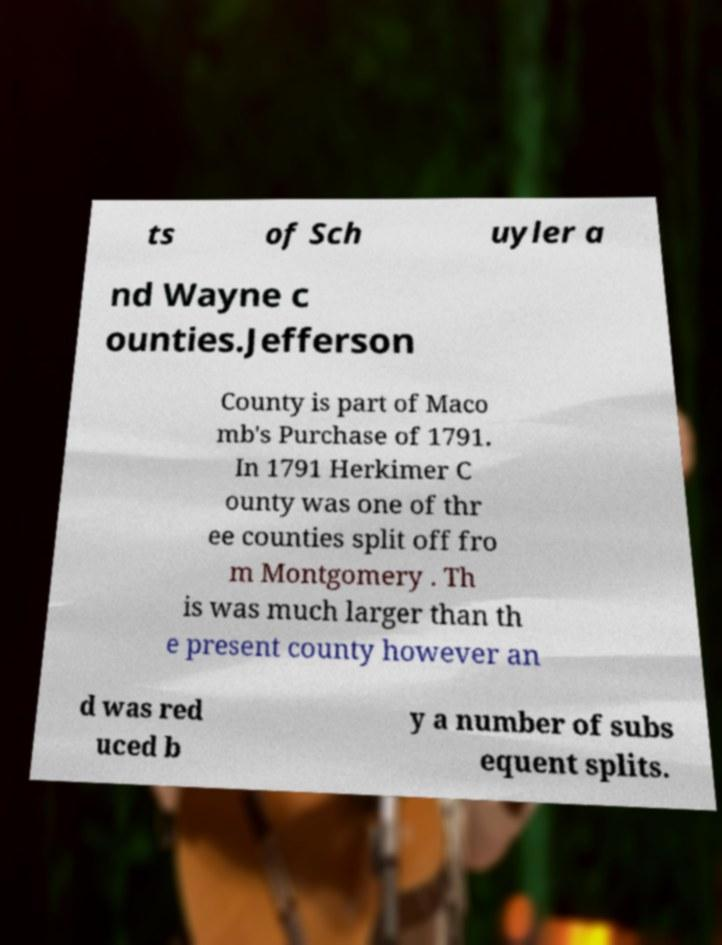Please identify and transcribe the text found in this image. ts of Sch uyler a nd Wayne c ounties.Jefferson County is part of Maco mb's Purchase of 1791. In 1791 Herkimer C ounty was one of thr ee counties split off fro m Montgomery . Th is was much larger than th e present county however an d was red uced b y a number of subs equent splits. 